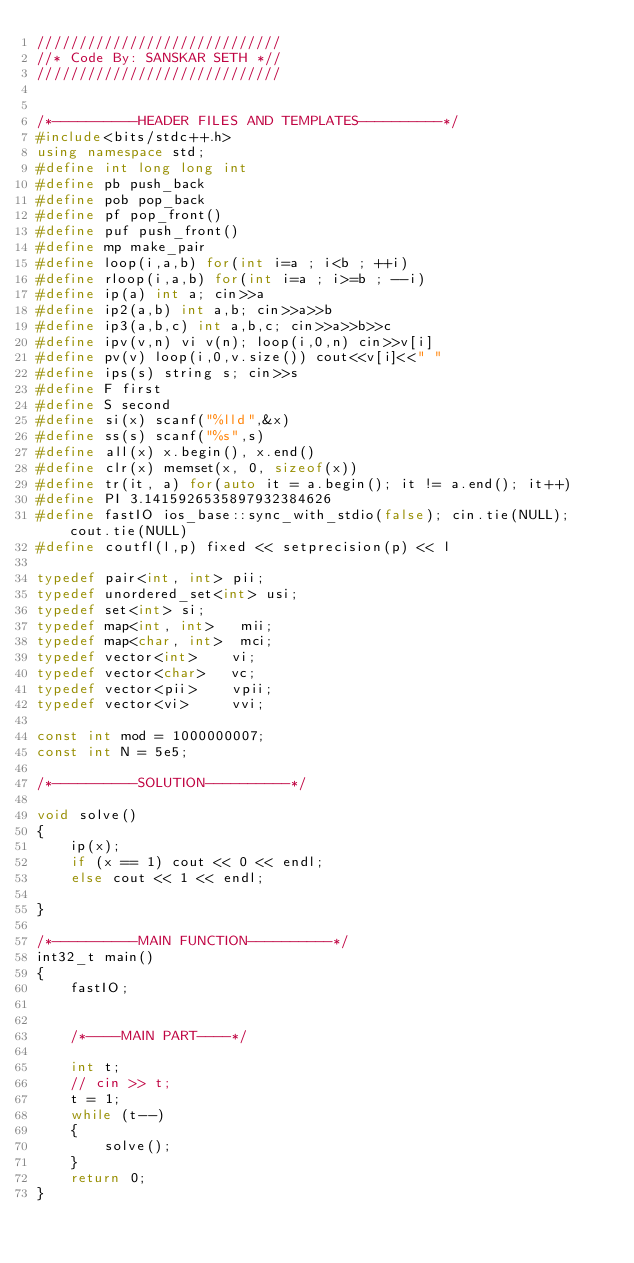Convert code to text. <code><loc_0><loc_0><loc_500><loc_500><_C++_>/////////////////////////////
//* Code By: SANSKAR SETH *//
/////////////////////////////


/*----------HEADER FILES AND TEMPLATES----------*/
#include<bits/stdc++.h>
using namespace std;
#define int long long int
#define pb push_back
#define pob pop_back
#define pf pop_front()
#define puf push_front()
#define mp make_pair
#define loop(i,a,b) for(int i=a ; i<b ; ++i)
#define rloop(i,a,b) for(int i=a ; i>=b ; --i)
#define ip(a) int a; cin>>a
#define ip2(a,b) int a,b; cin>>a>>b
#define ip3(a,b,c) int a,b,c; cin>>a>>b>>c
#define ipv(v,n) vi v(n); loop(i,0,n) cin>>v[i]
#define pv(v) loop(i,0,v.size()) cout<<v[i]<<" "
#define ips(s) string s; cin>>s
#define F first
#define S second
#define si(x) scanf("%lld",&x)
#define ss(s) scanf("%s",s)
#define all(x) x.begin(), x.end()
#define clr(x) memset(x, 0, sizeof(x))
#define tr(it, a) for(auto it = a.begin(); it != a.end(); it++)
#define PI 3.1415926535897932384626
#define fastIO ios_base::sync_with_stdio(false); cin.tie(NULL); cout.tie(NULL)
#define coutfl(l,p) fixed << setprecision(p) << l

typedef pair<int, int> pii;
typedef unordered_set<int> usi;
typedef set<int> si;
typedef map<int, int>   mii;
typedef map<char, int>  mci;
typedef vector<int>    vi;
typedef vector<char>   vc;
typedef vector<pii>    vpii;
typedef vector<vi>     vvi;

const int mod = 1000000007;
const int N = 5e5;

/*----------SOLUTION----------*/

void solve()
{
	ip(x);
	if (x == 1) cout << 0 << endl;
	else cout << 1 << endl;

}

/*----------MAIN FUNCTION----------*/
int32_t main()
{
	fastIO;


	/*----MAIN PART----*/

	int t;
	// cin >> t;
	t = 1;
	while (t--)
	{
		solve();
	}
	return 0;
}</code> 